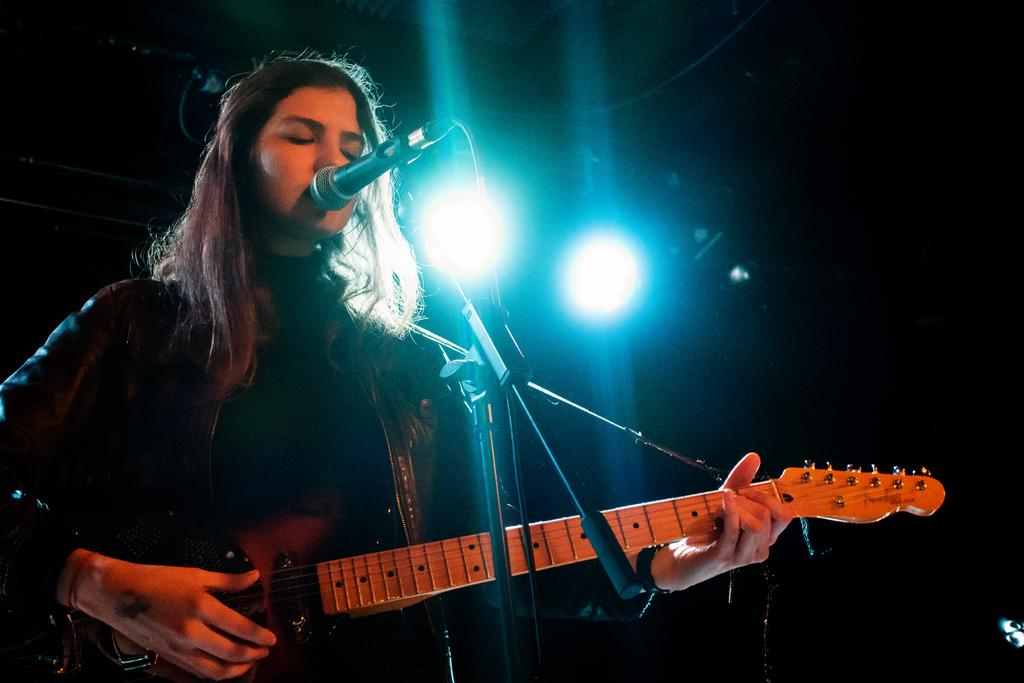Who is the main subject in the image? There is a woman in the image. What is the woman doing in the image? The woman is playing a guitar. What object is the woman standing in front of? The woman is in front of a microphone. What is present in front of the woman? There is a stand in front of the woman. What can be seen in the background of the image? There are lights visible in the background. What type of patch is the woman wearing on her shirt in the image? There is no patch visible on the woman's shirt in the image. 